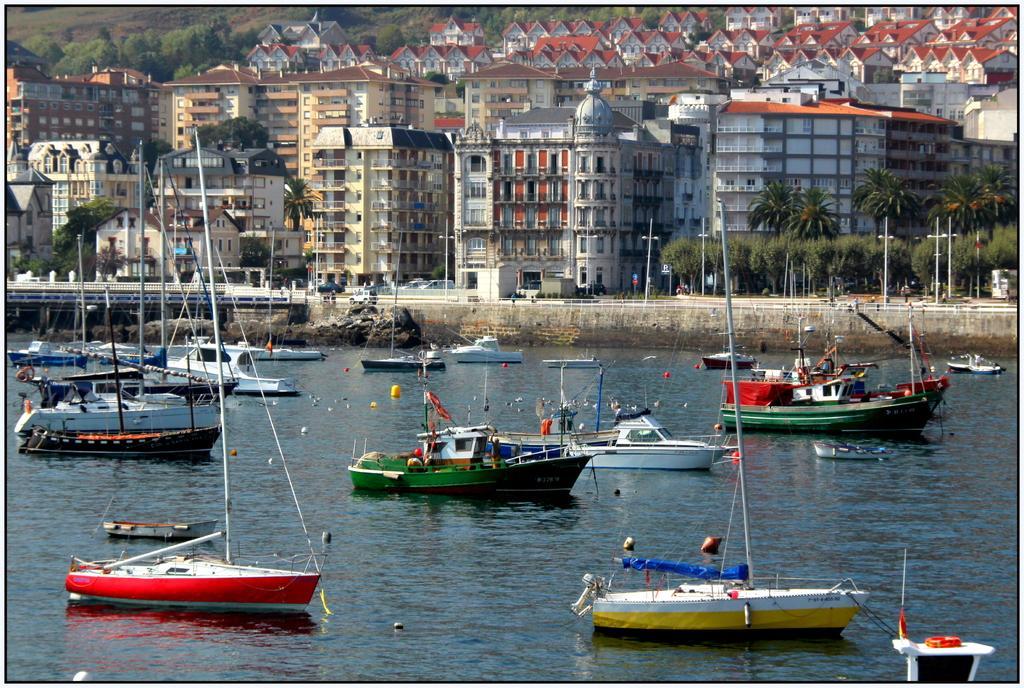Could you give a brief overview of what you see in this image? We can see ships and some objects above the water. We can see poles with strings. In the background we can see buildings,trees,vehicles,fence and poles. 